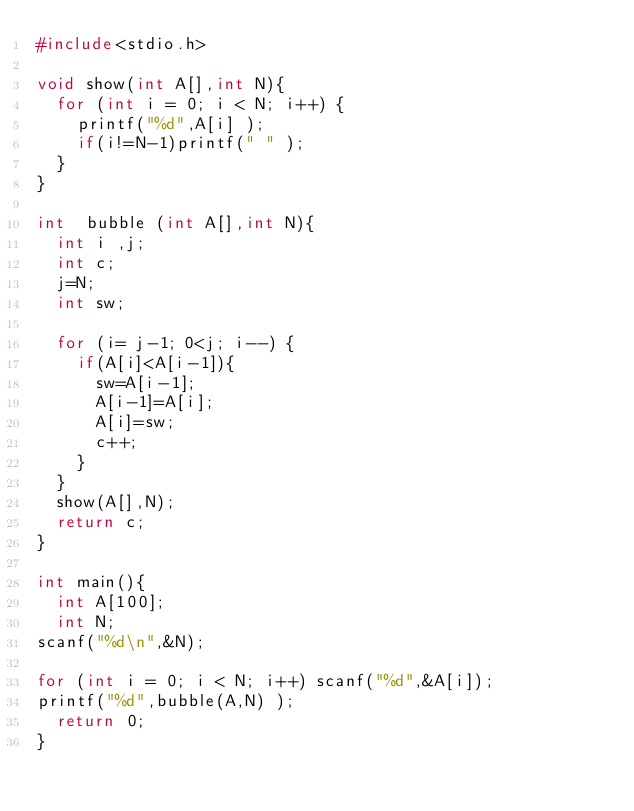<code> <loc_0><loc_0><loc_500><loc_500><_C_>#include<stdio.h>

void show(int A[],int N){
  for (int i = 0; i < N; i++) {
    printf("%d",A[i] );
    if(i!=N-1)printf(" " );
  }
}

int  bubble (int A[],int N){
  int i ,j;
  int c;
  j=N;
  int sw;
  
  for (i= j-1; 0<j; i--) {
    if(A[i]<A[i-1]){
      sw=A[i-1];
      A[i-1]=A[i];
      A[i]=sw;
      c++;
    }
  }
  show(A[],N);
  return c;
}

int main(){
  int A[100];
  int N;
scanf("%d\n",&N);

for (int i = 0; i < N; i++) scanf("%d",&A[i]);
printf("%d",bubble(A,N) );
  return 0;
}
</code> 